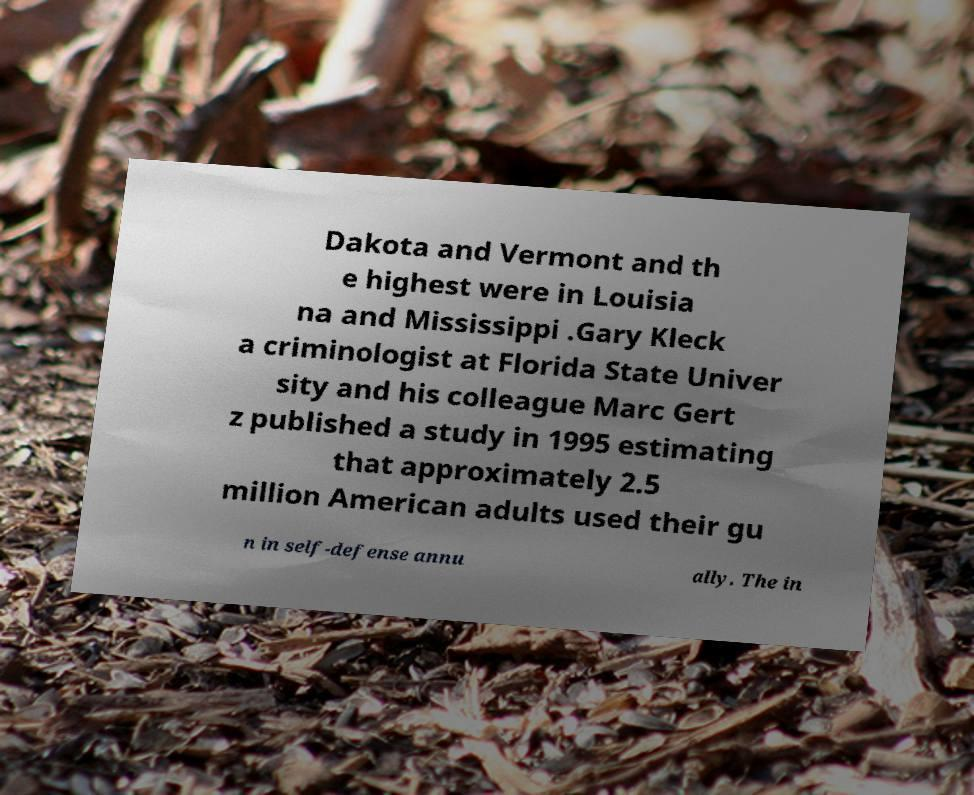Please read and relay the text visible in this image. What does it say? Dakota and Vermont and th e highest were in Louisia na and Mississippi .Gary Kleck a criminologist at Florida State Univer sity and his colleague Marc Gert z published a study in 1995 estimating that approximately 2.5 million American adults used their gu n in self-defense annu ally. The in 